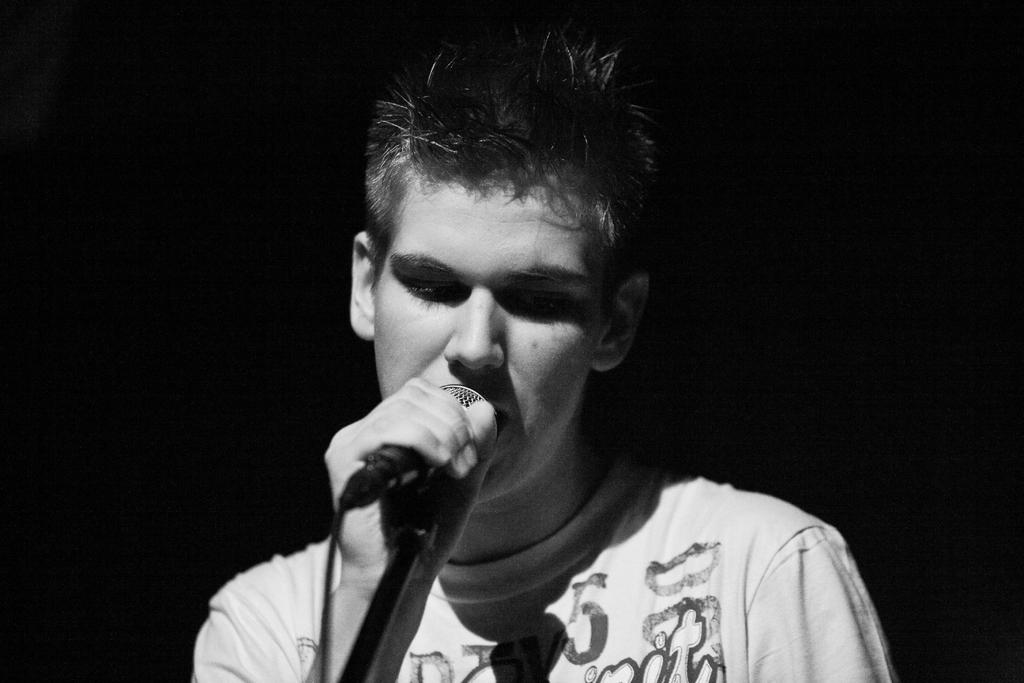What is the main subject of the image? The main subject of the image is a boy. What is the boy wearing? The boy is wearing a white t-shirt. What is the boy doing in the image? The boy is singing. What object is present in the image that is typically used for amplifying sound? There is a microphone in the image, which is attached to a stand. How is the boy interacting with the microphone stand? The boy is holding the stand with his left hand. What type of stove can be seen in the image? There is no stove present in the image. How does the size of the society affect the boy's performance in the image? The size of the society is not mentioned in the image, and therefore its impact on the boy's performance cannot be determined. 